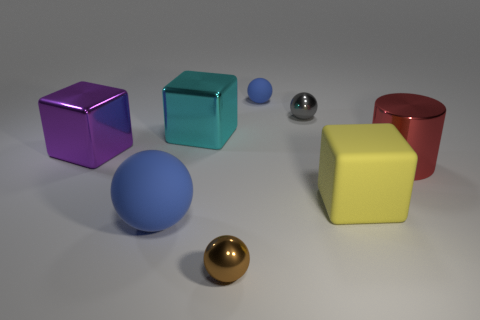What is the size of the object that is the same color as the small rubber ball?
Offer a terse response. Large. What number of other objects are there of the same material as the tiny gray object?
Provide a short and direct response. 4. What number of objects are tiny balls that are in front of the small blue matte object or large things left of the yellow rubber thing?
Offer a very short reply. 5. There is a gray thing that is the same shape as the tiny blue rubber object; what is it made of?
Make the answer very short. Metal. Is there a tiny shiny thing?
Your answer should be compact. Yes. How big is the shiny thing that is both behind the large purple metallic cube and on the left side of the tiny brown sphere?
Provide a succinct answer. Large. What is the shape of the big purple object?
Provide a short and direct response. Cube. Are there any tiny blue objects in front of the rubber ball in front of the cyan object?
Keep it short and to the point. No. There is a brown sphere that is the same size as the gray sphere; what material is it?
Make the answer very short. Metal. Is there a rubber cube that has the same size as the brown metallic object?
Provide a short and direct response. No. 